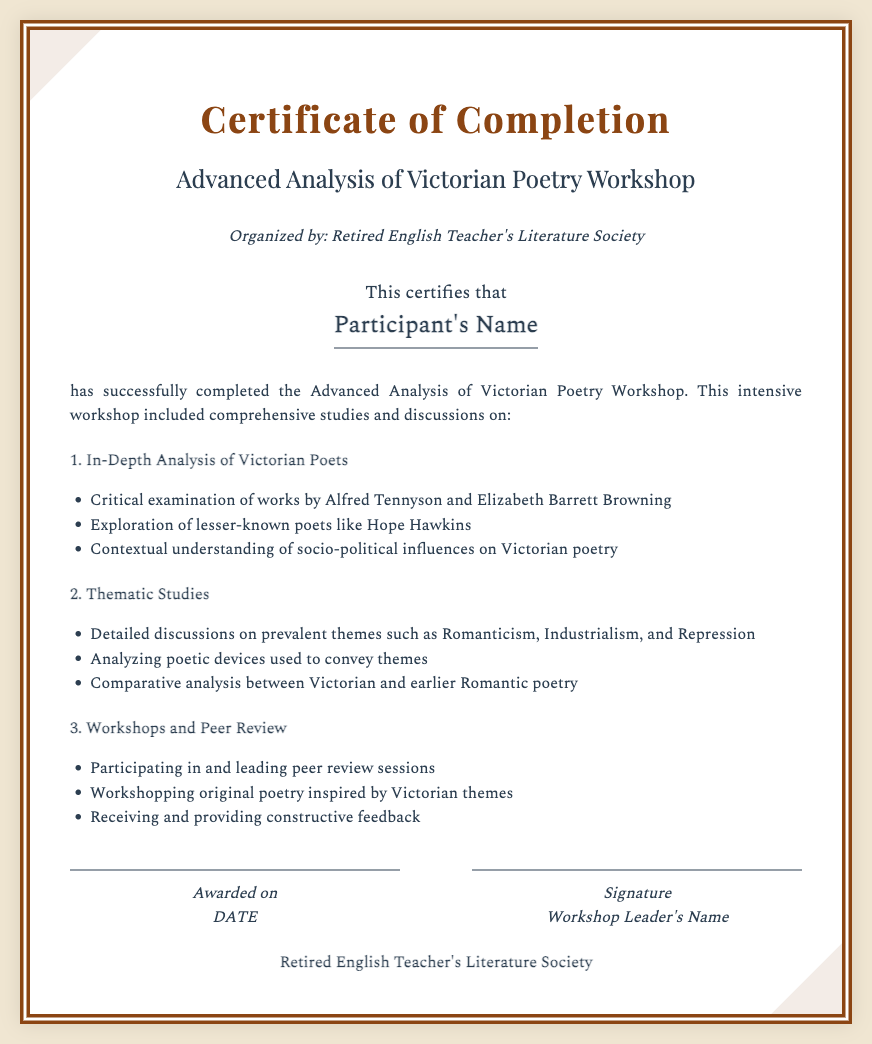What is the title of the workshop? The title of the workshop is clearly stated in the second header of the document.
Answer: Advanced Analysis of Victorian Poetry Workshop Who organized the workshop? The organization behind the workshop is mentioned in the awarding body section of the document.
Answer: Retired English Teacher's Literature Society Who is the recipient of the certificate? The recipient's name is specified in the designated area for the name on the certificate.
Answer: Participant's Name What date is the certificate awarded on? The awarded date placeholder indicates where the date would be displayed, although it is currently a placeholder.
Answer: DATE Which poet is mentioned alongside Elizabeth Barrett Browning and Alfred Tennyson? The list under In-Depth Analysis explicitly includes the lesser-known poet being referenced.
Answer: Hope Hawkins What theme is used to analyze the poets? The document outlines the themes discussed in the thematic studies section and mentions specific areas like Romanticism.
Answer: Romanticism What kind of sessions did the participants take part in? The workshops and peer review section details the nature of the participant engagement in the program.
Answer: Peer review sessions Which element is emphasized in the Thematic Studies section? The document indicates an area of focus in the thematic study of poetry, specified in a bullet point.
Answer: Analyzing poetic devices What is the layout style of the certificate? The overall design and framing of the certificate with specific attributes contribute to its aesthetic, which is highlighted in the document's style description.
Answer: Double border 